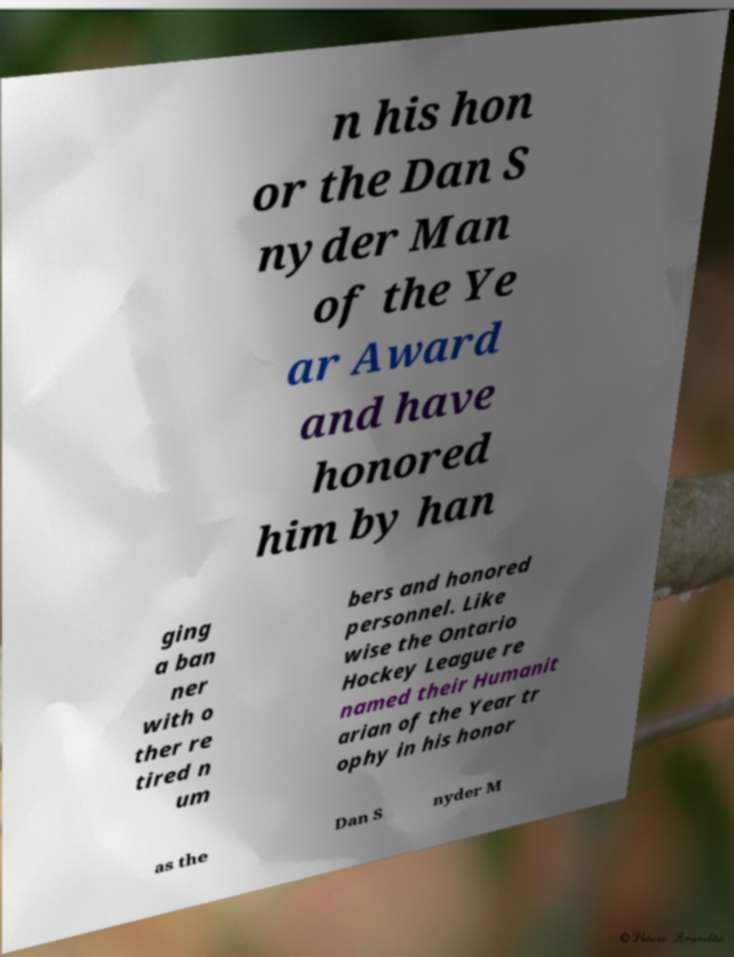Could you assist in decoding the text presented in this image and type it out clearly? n his hon or the Dan S nyder Man of the Ye ar Award and have honored him by han ging a ban ner with o ther re tired n um bers and honored personnel. Like wise the Ontario Hockey League re named their Humanit arian of the Year tr ophy in his honor as the Dan S nyder M 